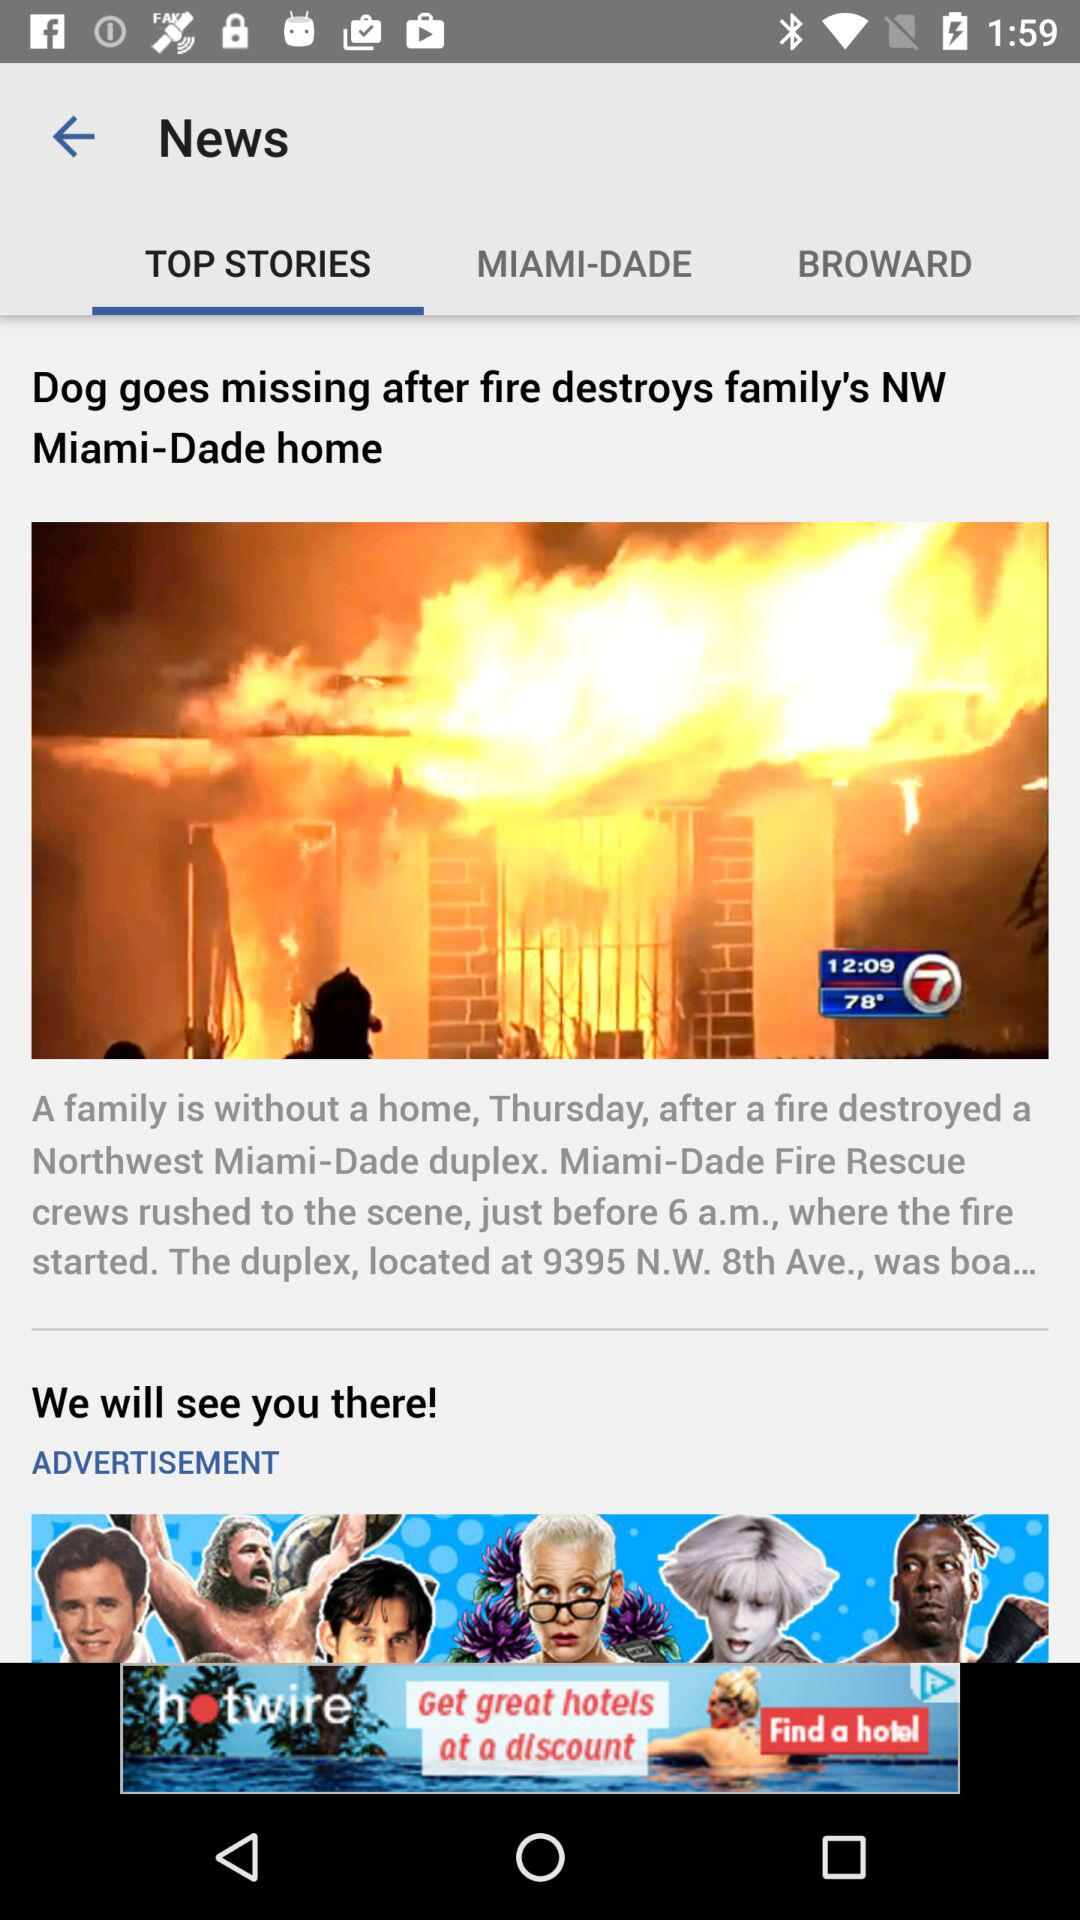On what day did a fire destroy a family in Miami?
Answer the question using a single word or phrase. The day is "Thursday." 